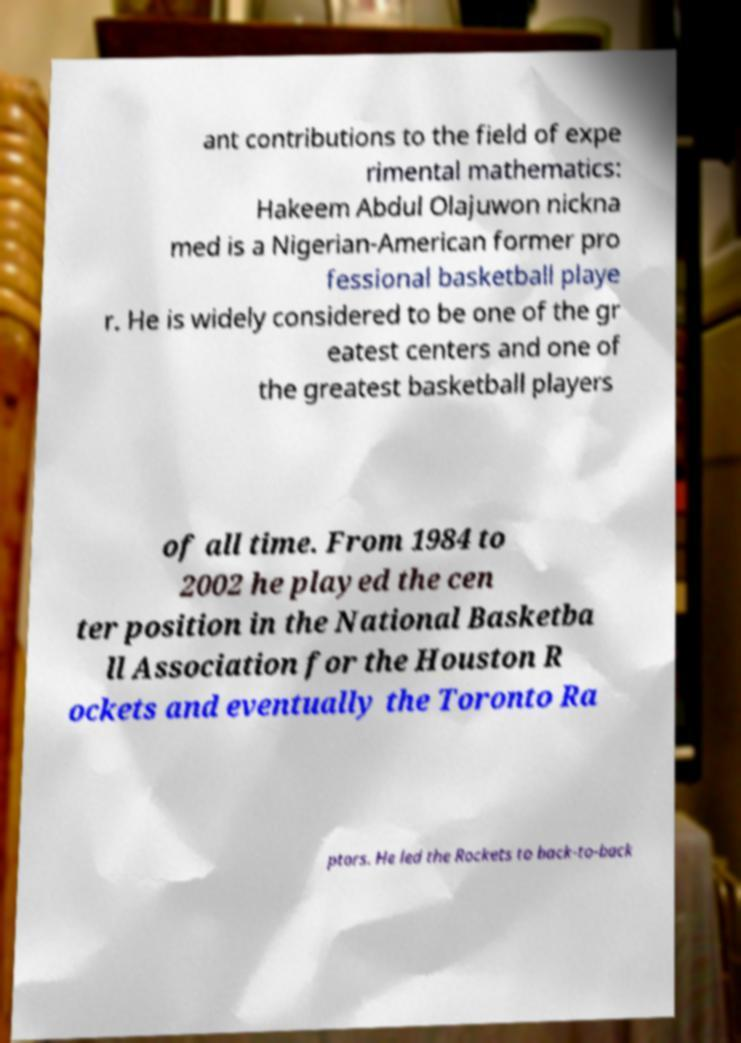Can you read and provide the text displayed in the image?This photo seems to have some interesting text. Can you extract and type it out for me? ant contributions to the field of expe rimental mathematics: Hakeem Abdul Olajuwon nickna med is a Nigerian-American former pro fessional basketball playe r. He is widely considered to be one of the gr eatest centers and one of the greatest basketball players of all time. From 1984 to 2002 he played the cen ter position in the National Basketba ll Association for the Houston R ockets and eventually the Toronto Ra ptors. He led the Rockets to back-to-back 